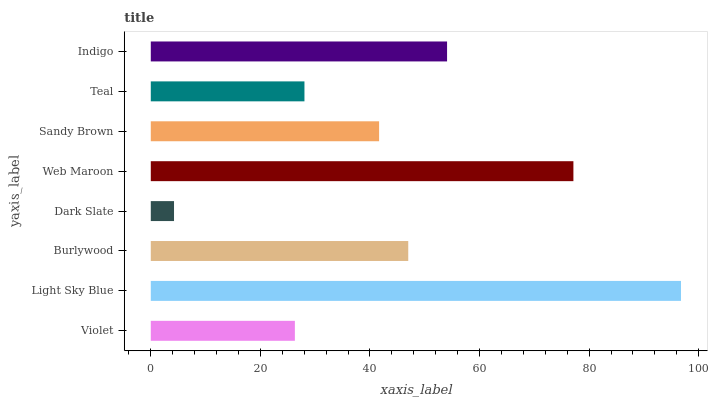Is Dark Slate the minimum?
Answer yes or no. Yes. Is Light Sky Blue the maximum?
Answer yes or no. Yes. Is Burlywood the minimum?
Answer yes or no. No. Is Burlywood the maximum?
Answer yes or no. No. Is Light Sky Blue greater than Burlywood?
Answer yes or no. Yes. Is Burlywood less than Light Sky Blue?
Answer yes or no. Yes. Is Burlywood greater than Light Sky Blue?
Answer yes or no. No. Is Light Sky Blue less than Burlywood?
Answer yes or no. No. Is Burlywood the high median?
Answer yes or no. Yes. Is Sandy Brown the low median?
Answer yes or no. Yes. Is Indigo the high median?
Answer yes or no. No. Is Indigo the low median?
Answer yes or no. No. 